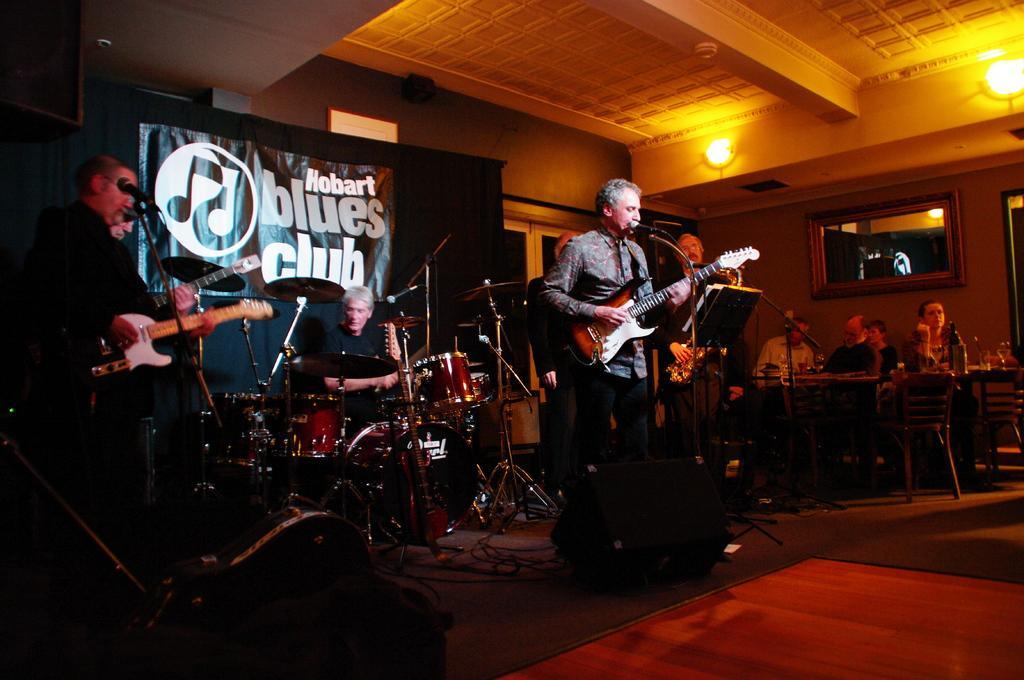In one or two sentences, can you explain what this image depicts? As we can see in the image there are lights, wall, mirror, banner, few people sitting and few of them are standing and there are chairs and tables. The men who are standing here are holding guitars and this man is playing musical drums. 